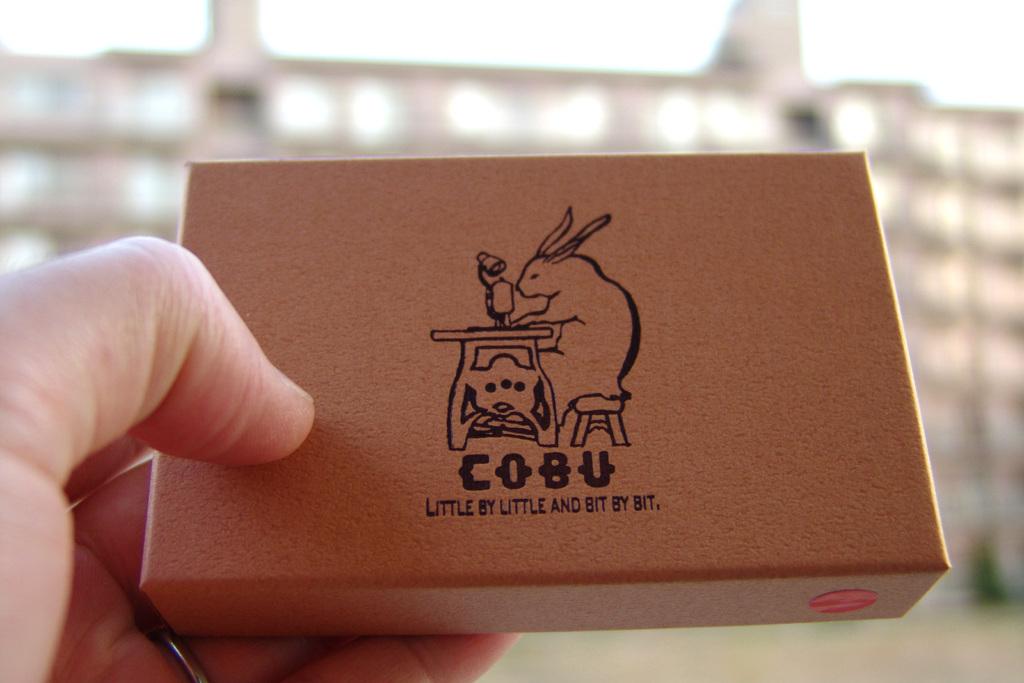What does the text say underneath cobu?
Give a very brief answer. Little by little and bit by bit. What is the brand of this product?
Offer a very short reply. Cobu. 